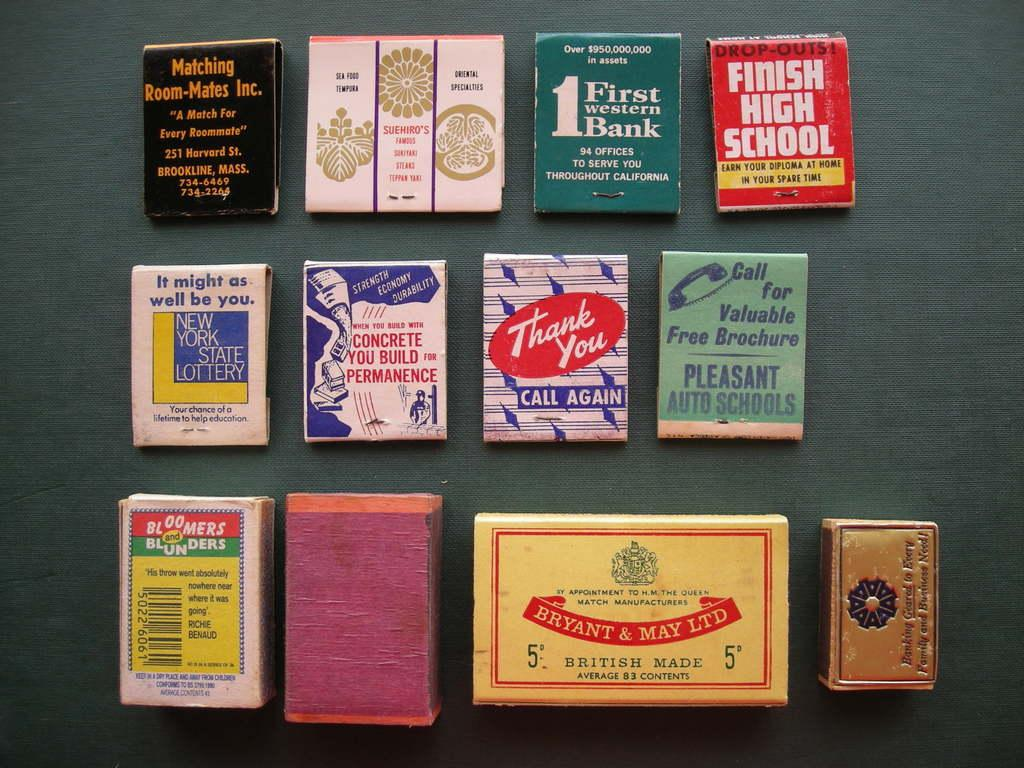<image>
Give a short and clear explanation of the subsequent image. A grouping of books with one titled Finish High School. 